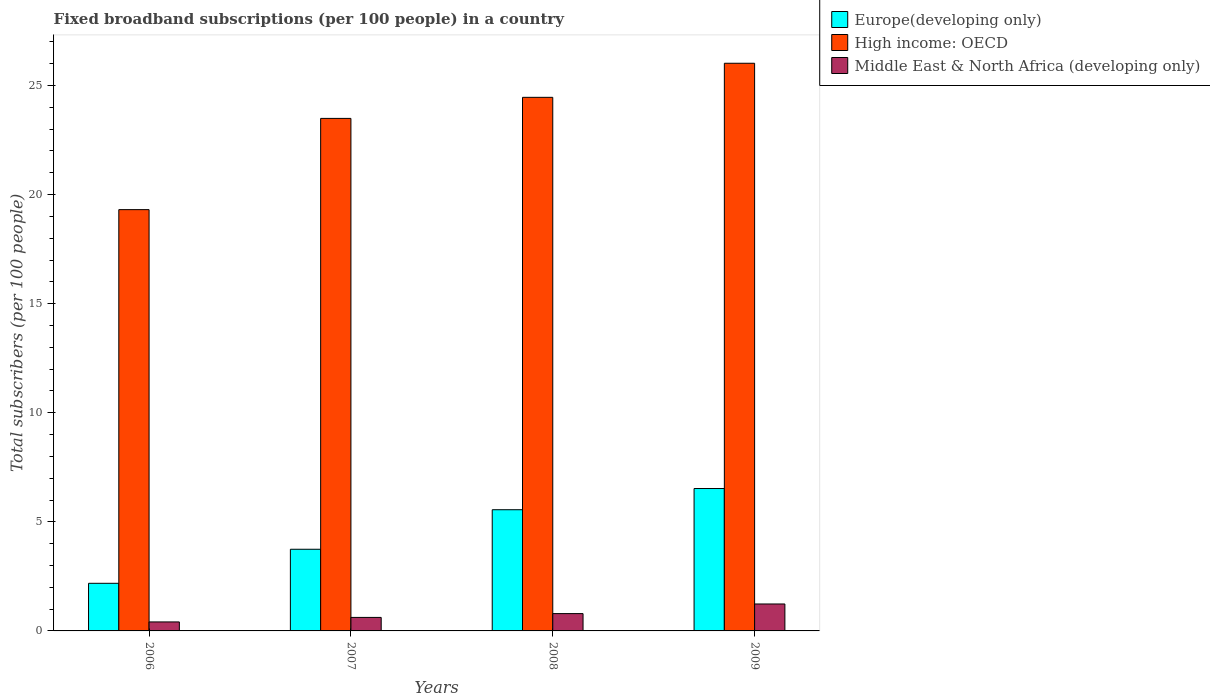How many groups of bars are there?
Give a very brief answer. 4. Are the number of bars per tick equal to the number of legend labels?
Make the answer very short. Yes. Are the number of bars on each tick of the X-axis equal?
Make the answer very short. Yes. How many bars are there on the 1st tick from the left?
Offer a very short reply. 3. How many bars are there on the 2nd tick from the right?
Provide a short and direct response. 3. In how many cases, is the number of bars for a given year not equal to the number of legend labels?
Your response must be concise. 0. What is the number of broadband subscriptions in High income: OECD in 2006?
Offer a very short reply. 19.31. Across all years, what is the maximum number of broadband subscriptions in High income: OECD?
Your answer should be compact. 26.02. Across all years, what is the minimum number of broadband subscriptions in Europe(developing only)?
Offer a terse response. 2.18. In which year was the number of broadband subscriptions in Middle East & North Africa (developing only) minimum?
Your answer should be compact. 2006. What is the total number of broadband subscriptions in Middle East & North Africa (developing only) in the graph?
Keep it short and to the point. 3.06. What is the difference between the number of broadband subscriptions in High income: OECD in 2008 and that in 2009?
Provide a short and direct response. -1.56. What is the difference between the number of broadband subscriptions in Europe(developing only) in 2009 and the number of broadband subscriptions in Middle East & North Africa (developing only) in 2006?
Provide a short and direct response. 6.11. What is the average number of broadband subscriptions in Europe(developing only) per year?
Ensure brevity in your answer.  4.5. In the year 2009, what is the difference between the number of broadband subscriptions in Middle East & North Africa (developing only) and number of broadband subscriptions in Europe(developing only)?
Your answer should be very brief. -5.29. What is the ratio of the number of broadband subscriptions in High income: OECD in 2007 to that in 2008?
Provide a succinct answer. 0.96. Is the number of broadband subscriptions in Europe(developing only) in 2007 less than that in 2009?
Ensure brevity in your answer.  Yes. Is the difference between the number of broadband subscriptions in Middle East & North Africa (developing only) in 2008 and 2009 greater than the difference between the number of broadband subscriptions in Europe(developing only) in 2008 and 2009?
Offer a terse response. Yes. What is the difference between the highest and the second highest number of broadband subscriptions in Middle East & North Africa (developing only)?
Give a very brief answer. 0.44. What is the difference between the highest and the lowest number of broadband subscriptions in Europe(developing only)?
Offer a very short reply. 4.34. Is the sum of the number of broadband subscriptions in Middle East & North Africa (developing only) in 2006 and 2008 greater than the maximum number of broadband subscriptions in High income: OECD across all years?
Make the answer very short. No. What does the 2nd bar from the left in 2007 represents?
Offer a very short reply. High income: OECD. What does the 3rd bar from the right in 2007 represents?
Your answer should be compact. Europe(developing only). Is it the case that in every year, the sum of the number of broadband subscriptions in Middle East & North Africa (developing only) and number of broadband subscriptions in Europe(developing only) is greater than the number of broadband subscriptions in High income: OECD?
Make the answer very short. No. How many bars are there?
Your answer should be compact. 12. Are all the bars in the graph horizontal?
Make the answer very short. No. How many years are there in the graph?
Provide a succinct answer. 4. What is the difference between two consecutive major ticks on the Y-axis?
Give a very brief answer. 5. How many legend labels are there?
Provide a short and direct response. 3. How are the legend labels stacked?
Offer a very short reply. Vertical. What is the title of the graph?
Make the answer very short. Fixed broadband subscriptions (per 100 people) in a country. Does "Liberia" appear as one of the legend labels in the graph?
Ensure brevity in your answer.  No. What is the label or title of the X-axis?
Ensure brevity in your answer.  Years. What is the label or title of the Y-axis?
Make the answer very short. Total subscribers (per 100 people). What is the Total subscribers (per 100 people) in Europe(developing only) in 2006?
Make the answer very short. 2.18. What is the Total subscribers (per 100 people) in High income: OECD in 2006?
Your answer should be compact. 19.31. What is the Total subscribers (per 100 people) in Middle East & North Africa (developing only) in 2006?
Offer a terse response. 0.41. What is the Total subscribers (per 100 people) of Europe(developing only) in 2007?
Make the answer very short. 3.74. What is the Total subscribers (per 100 people) in High income: OECD in 2007?
Keep it short and to the point. 23.49. What is the Total subscribers (per 100 people) in Middle East & North Africa (developing only) in 2007?
Your response must be concise. 0.62. What is the Total subscribers (per 100 people) in Europe(developing only) in 2008?
Make the answer very short. 5.56. What is the Total subscribers (per 100 people) of High income: OECD in 2008?
Ensure brevity in your answer.  24.46. What is the Total subscribers (per 100 people) of Middle East & North Africa (developing only) in 2008?
Ensure brevity in your answer.  0.79. What is the Total subscribers (per 100 people) in Europe(developing only) in 2009?
Your response must be concise. 6.53. What is the Total subscribers (per 100 people) of High income: OECD in 2009?
Provide a short and direct response. 26.02. What is the Total subscribers (per 100 people) in Middle East & North Africa (developing only) in 2009?
Provide a short and direct response. 1.23. Across all years, what is the maximum Total subscribers (per 100 people) in Europe(developing only)?
Your response must be concise. 6.53. Across all years, what is the maximum Total subscribers (per 100 people) of High income: OECD?
Make the answer very short. 26.02. Across all years, what is the maximum Total subscribers (per 100 people) of Middle East & North Africa (developing only)?
Offer a terse response. 1.23. Across all years, what is the minimum Total subscribers (per 100 people) of Europe(developing only)?
Offer a very short reply. 2.18. Across all years, what is the minimum Total subscribers (per 100 people) in High income: OECD?
Offer a terse response. 19.31. Across all years, what is the minimum Total subscribers (per 100 people) in Middle East & North Africa (developing only)?
Offer a terse response. 0.41. What is the total Total subscribers (per 100 people) of Europe(developing only) in the graph?
Give a very brief answer. 18.01. What is the total Total subscribers (per 100 people) in High income: OECD in the graph?
Your response must be concise. 93.28. What is the total Total subscribers (per 100 people) in Middle East & North Africa (developing only) in the graph?
Provide a succinct answer. 3.06. What is the difference between the Total subscribers (per 100 people) of Europe(developing only) in 2006 and that in 2007?
Provide a succinct answer. -1.56. What is the difference between the Total subscribers (per 100 people) in High income: OECD in 2006 and that in 2007?
Ensure brevity in your answer.  -4.18. What is the difference between the Total subscribers (per 100 people) of Middle East & North Africa (developing only) in 2006 and that in 2007?
Keep it short and to the point. -0.21. What is the difference between the Total subscribers (per 100 people) in Europe(developing only) in 2006 and that in 2008?
Provide a succinct answer. -3.37. What is the difference between the Total subscribers (per 100 people) in High income: OECD in 2006 and that in 2008?
Ensure brevity in your answer.  -5.15. What is the difference between the Total subscribers (per 100 people) in Middle East & North Africa (developing only) in 2006 and that in 2008?
Provide a short and direct response. -0.38. What is the difference between the Total subscribers (per 100 people) of Europe(developing only) in 2006 and that in 2009?
Make the answer very short. -4.34. What is the difference between the Total subscribers (per 100 people) in High income: OECD in 2006 and that in 2009?
Offer a very short reply. -6.71. What is the difference between the Total subscribers (per 100 people) in Middle East & North Africa (developing only) in 2006 and that in 2009?
Ensure brevity in your answer.  -0.82. What is the difference between the Total subscribers (per 100 people) in Europe(developing only) in 2007 and that in 2008?
Your response must be concise. -1.81. What is the difference between the Total subscribers (per 100 people) in High income: OECD in 2007 and that in 2008?
Provide a succinct answer. -0.97. What is the difference between the Total subscribers (per 100 people) in Middle East & North Africa (developing only) in 2007 and that in 2008?
Offer a very short reply. -0.18. What is the difference between the Total subscribers (per 100 people) of Europe(developing only) in 2007 and that in 2009?
Ensure brevity in your answer.  -2.78. What is the difference between the Total subscribers (per 100 people) of High income: OECD in 2007 and that in 2009?
Ensure brevity in your answer.  -2.53. What is the difference between the Total subscribers (per 100 people) of Middle East & North Africa (developing only) in 2007 and that in 2009?
Offer a very short reply. -0.62. What is the difference between the Total subscribers (per 100 people) of Europe(developing only) in 2008 and that in 2009?
Your answer should be very brief. -0.97. What is the difference between the Total subscribers (per 100 people) of High income: OECD in 2008 and that in 2009?
Offer a terse response. -1.56. What is the difference between the Total subscribers (per 100 people) of Middle East & North Africa (developing only) in 2008 and that in 2009?
Keep it short and to the point. -0.44. What is the difference between the Total subscribers (per 100 people) of Europe(developing only) in 2006 and the Total subscribers (per 100 people) of High income: OECD in 2007?
Your answer should be compact. -21.31. What is the difference between the Total subscribers (per 100 people) of Europe(developing only) in 2006 and the Total subscribers (per 100 people) of Middle East & North Africa (developing only) in 2007?
Ensure brevity in your answer.  1.56. What is the difference between the Total subscribers (per 100 people) of High income: OECD in 2006 and the Total subscribers (per 100 people) of Middle East & North Africa (developing only) in 2007?
Keep it short and to the point. 18.69. What is the difference between the Total subscribers (per 100 people) of Europe(developing only) in 2006 and the Total subscribers (per 100 people) of High income: OECD in 2008?
Offer a very short reply. -22.27. What is the difference between the Total subscribers (per 100 people) in Europe(developing only) in 2006 and the Total subscribers (per 100 people) in Middle East & North Africa (developing only) in 2008?
Your response must be concise. 1.39. What is the difference between the Total subscribers (per 100 people) in High income: OECD in 2006 and the Total subscribers (per 100 people) in Middle East & North Africa (developing only) in 2008?
Provide a succinct answer. 18.52. What is the difference between the Total subscribers (per 100 people) in Europe(developing only) in 2006 and the Total subscribers (per 100 people) in High income: OECD in 2009?
Give a very brief answer. -23.84. What is the difference between the Total subscribers (per 100 people) in Europe(developing only) in 2006 and the Total subscribers (per 100 people) in Middle East & North Africa (developing only) in 2009?
Provide a short and direct response. 0.95. What is the difference between the Total subscribers (per 100 people) of High income: OECD in 2006 and the Total subscribers (per 100 people) of Middle East & North Africa (developing only) in 2009?
Provide a short and direct response. 18.08. What is the difference between the Total subscribers (per 100 people) of Europe(developing only) in 2007 and the Total subscribers (per 100 people) of High income: OECD in 2008?
Make the answer very short. -20.71. What is the difference between the Total subscribers (per 100 people) of Europe(developing only) in 2007 and the Total subscribers (per 100 people) of Middle East & North Africa (developing only) in 2008?
Ensure brevity in your answer.  2.95. What is the difference between the Total subscribers (per 100 people) in High income: OECD in 2007 and the Total subscribers (per 100 people) in Middle East & North Africa (developing only) in 2008?
Your response must be concise. 22.7. What is the difference between the Total subscribers (per 100 people) in Europe(developing only) in 2007 and the Total subscribers (per 100 people) in High income: OECD in 2009?
Give a very brief answer. -22.28. What is the difference between the Total subscribers (per 100 people) in Europe(developing only) in 2007 and the Total subscribers (per 100 people) in Middle East & North Africa (developing only) in 2009?
Ensure brevity in your answer.  2.51. What is the difference between the Total subscribers (per 100 people) of High income: OECD in 2007 and the Total subscribers (per 100 people) of Middle East & North Africa (developing only) in 2009?
Make the answer very short. 22.26. What is the difference between the Total subscribers (per 100 people) in Europe(developing only) in 2008 and the Total subscribers (per 100 people) in High income: OECD in 2009?
Ensure brevity in your answer.  -20.46. What is the difference between the Total subscribers (per 100 people) of Europe(developing only) in 2008 and the Total subscribers (per 100 people) of Middle East & North Africa (developing only) in 2009?
Ensure brevity in your answer.  4.32. What is the difference between the Total subscribers (per 100 people) of High income: OECD in 2008 and the Total subscribers (per 100 people) of Middle East & North Africa (developing only) in 2009?
Provide a short and direct response. 23.22. What is the average Total subscribers (per 100 people) of Europe(developing only) per year?
Offer a terse response. 4.5. What is the average Total subscribers (per 100 people) of High income: OECD per year?
Provide a short and direct response. 23.32. What is the average Total subscribers (per 100 people) of Middle East & North Africa (developing only) per year?
Provide a short and direct response. 0.77. In the year 2006, what is the difference between the Total subscribers (per 100 people) in Europe(developing only) and Total subscribers (per 100 people) in High income: OECD?
Keep it short and to the point. -17.13. In the year 2006, what is the difference between the Total subscribers (per 100 people) in Europe(developing only) and Total subscribers (per 100 people) in Middle East & North Africa (developing only)?
Give a very brief answer. 1.77. In the year 2006, what is the difference between the Total subscribers (per 100 people) of High income: OECD and Total subscribers (per 100 people) of Middle East & North Africa (developing only)?
Provide a succinct answer. 18.9. In the year 2007, what is the difference between the Total subscribers (per 100 people) of Europe(developing only) and Total subscribers (per 100 people) of High income: OECD?
Provide a short and direct response. -19.75. In the year 2007, what is the difference between the Total subscribers (per 100 people) in Europe(developing only) and Total subscribers (per 100 people) in Middle East & North Africa (developing only)?
Your answer should be compact. 3.12. In the year 2007, what is the difference between the Total subscribers (per 100 people) in High income: OECD and Total subscribers (per 100 people) in Middle East & North Africa (developing only)?
Give a very brief answer. 22.87. In the year 2008, what is the difference between the Total subscribers (per 100 people) of Europe(developing only) and Total subscribers (per 100 people) of High income: OECD?
Provide a short and direct response. -18.9. In the year 2008, what is the difference between the Total subscribers (per 100 people) in Europe(developing only) and Total subscribers (per 100 people) in Middle East & North Africa (developing only)?
Your response must be concise. 4.76. In the year 2008, what is the difference between the Total subscribers (per 100 people) of High income: OECD and Total subscribers (per 100 people) of Middle East & North Africa (developing only)?
Provide a succinct answer. 23.66. In the year 2009, what is the difference between the Total subscribers (per 100 people) of Europe(developing only) and Total subscribers (per 100 people) of High income: OECD?
Provide a succinct answer. -19.49. In the year 2009, what is the difference between the Total subscribers (per 100 people) in Europe(developing only) and Total subscribers (per 100 people) in Middle East & North Africa (developing only)?
Make the answer very short. 5.29. In the year 2009, what is the difference between the Total subscribers (per 100 people) of High income: OECD and Total subscribers (per 100 people) of Middle East & North Africa (developing only)?
Ensure brevity in your answer.  24.78. What is the ratio of the Total subscribers (per 100 people) in Europe(developing only) in 2006 to that in 2007?
Provide a succinct answer. 0.58. What is the ratio of the Total subscribers (per 100 people) in High income: OECD in 2006 to that in 2007?
Make the answer very short. 0.82. What is the ratio of the Total subscribers (per 100 people) in Middle East & North Africa (developing only) in 2006 to that in 2007?
Give a very brief answer. 0.67. What is the ratio of the Total subscribers (per 100 people) in Europe(developing only) in 2006 to that in 2008?
Provide a short and direct response. 0.39. What is the ratio of the Total subscribers (per 100 people) in High income: OECD in 2006 to that in 2008?
Make the answer very short. 0.79. What is the ratio of the Total subscribers (per 100 people) in Middle East & North Africa (developing only) in 2006 to that in 2008?
Your response must be concise. 0.52. What is the ratio of the Total subscribers (per 100 people) of Europe(developing only) in 2006 to that in 2009?
Make the answer very short. 0.33. What is the ratio of the Total subscribers (per 100 people) in High income: OECD in 2006 to that in 2009?
Your answer should be compact. 0.74. What is the ratio of the Total subscribers (per 100 people) in Middle East & North Africa (developing only) in 2006 to that in 2009?
Your answer should be very brief. 0.33. What is the ratio of the Total subscribers (per 100 people) of Europe(developing only) in 2007 to that in 2008?
Provide a short and direct response. 0.67. What is the ratio of the Total subscribers (per 100 people) of High income: OECD in 2007 to that in 2008?
Offer a very short reply. 0.96. What is the ratio of the Total subscribers (per 100 people) of Middle East & North Africa (developing only) in 2007 to that in 2008?
Provide a short and direct response. 0.78. What is the ratio of the Total subscribers (per 100 people) of Europe(developing only) in 2007 to that in 2009?
Your answer should be very brief. 0.57. What is the ratio of the Total subscribers (per 100 people) of High income: OECD in 2007 to that in 2009?
Offer a very short reply. 0.9. What is the ratio of the Total subscribers (per 100 people) of Middle East & North Africa (developing only) in 2007 to that in 2009?
Keep it short and to the point. 0.5. What is the ratio of the Total subscribers (per 100 people) of Europe(developing only) in 2008 to that in 2009?
Your answer should be compact. 0.85. What is the ratio of the Total subscribers (per 100 people) in High income: OECD in 2008 to that in 2009?
Offer a terse response. 0.94. What is the ratio of the Total subscribers (per 100 people) in Middle East & North Africa (developing only) in 2008 to that in 2009?
Offer a terse response. 0.64. What is the difference between the highest and the second highest Total subscribers (per 100 people) in Europe(developing only)?
Your answer should be compact. 0.97. What is the difference between the highest and the second highest Total subscribers (per 100 people) in High income: OECD?
Make the answer very short. 1.56. What is the difference between the highest and the second highest Total subscribers (per 100 people) in Middle East & North Africa (developing only)?
Make the answer very short. 0.44. What is the difference between the highest and the lowest Total subscribers (per 100 people) of Europe(developing only)?
Provide a succinct answer. 4.34. What is the difference between the highest and the lowest Total subscribers (per 100 people) in High income: OECD?
Your answer should be compact. 6.71. What is the difference between the highest and the lowest Total subscribers (per 100 people) of Middle East & North Africa (developing only)?
Your answer should be compact. 0.82. 